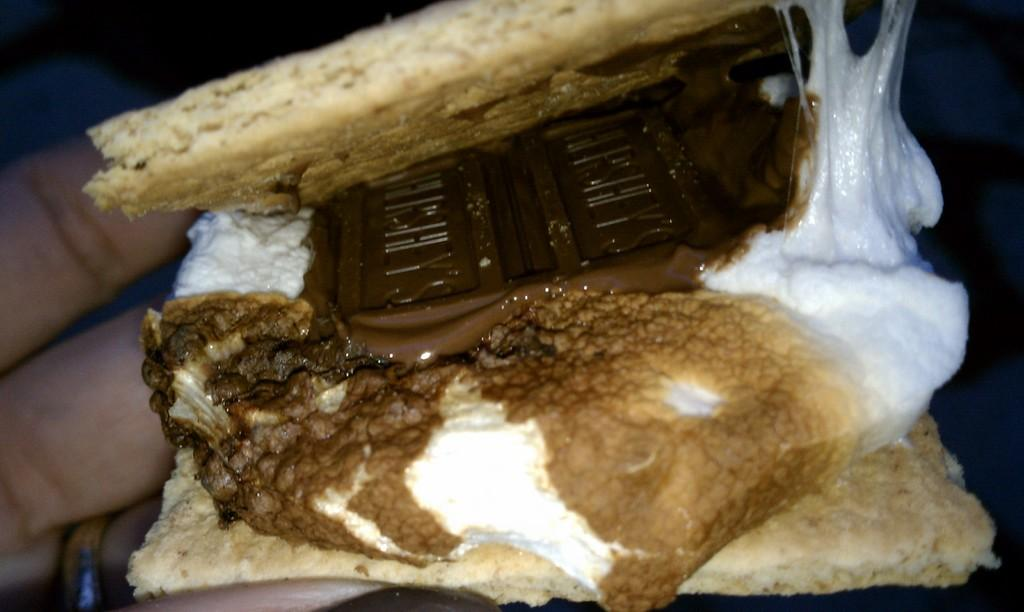What is present in the image? There is a person in the image. What is the person doing in the image? The person is holding food in their hand. What type of skirt is the person wearing in the image? There is no information about a skirt in the image, as the person is holding food in their hand. 